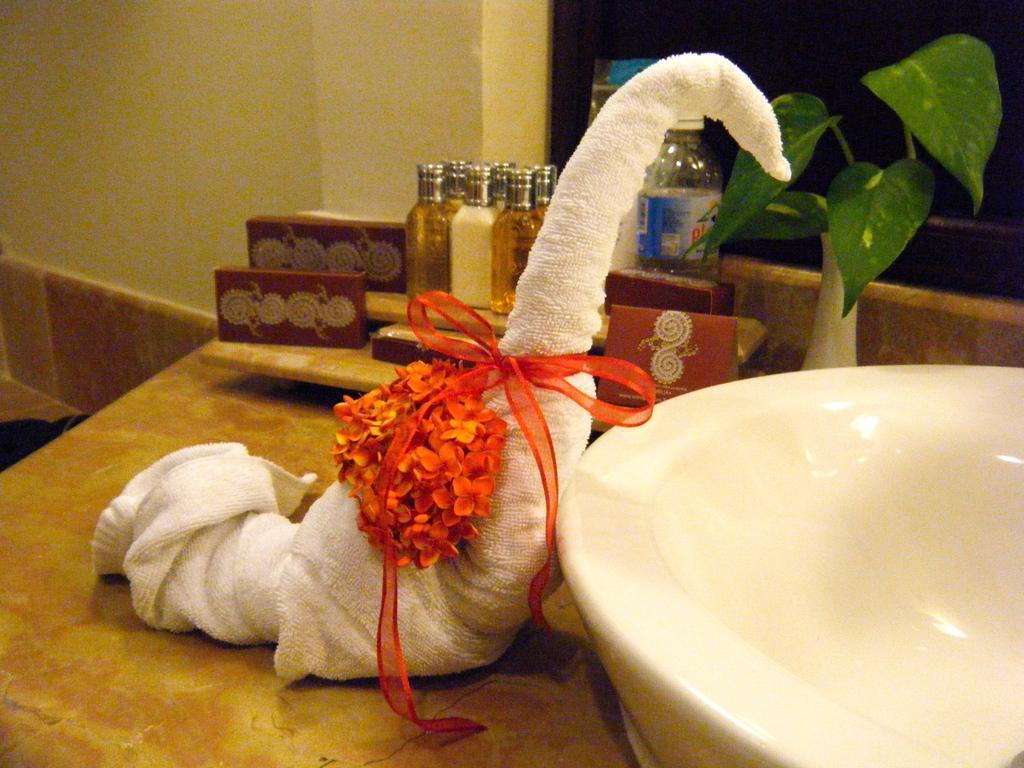Could you give a brief overview of what you see in this image? In this image we can see a towel is shaped in a bird's manner and tied a ribbon and kept some flowers. On the right side of the image we can see wash basin and money plant. 